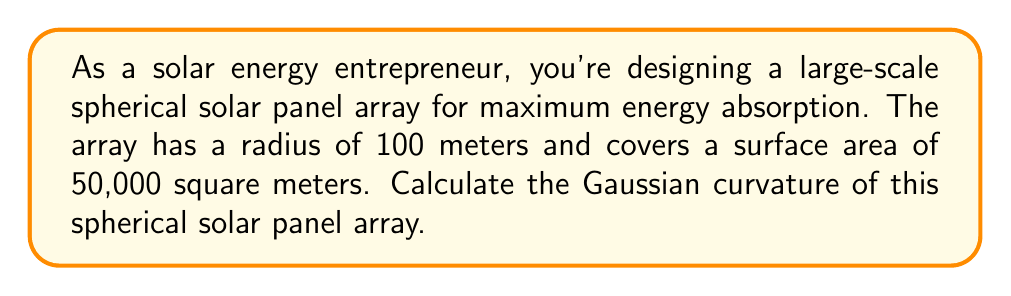Give your solution to this math problem. Let's approach this step-by-step:

1) The Gaussian curvature ($K$) of a sphere is constant and given by the formula:

   $$K = \frac{1}{R^2}$$

   where $R$ is the radius of the sphere.

2) We're given that the radius of the spherical array is 100 meters. Let's substitute this into our formula:

   $$K = \frac{1}{(100\text{ m})^2} = \frac{1}{10,000\text{ m}^2}$$

3) To simplify:
   
   $$K = 0.0001\text{ m}^{-2}$$

4) Note: We can verify our answer using the given surface area. The surface area of a sphere is given by $4\pi R^2$. With $R = 100\text{ m}$:

   $$4\pi(100\text{ m})^2 = 125,663.7\text{ m}^2$$

   The given surface area of 50,000 m² is less than this, which is consistent with a partial spherical array.

[asy]
import geometry;

size(200);
draw(Circle((0,0),1));
draw((0,0)--(1,0),Arrow);
label("R",(0.5,0),S);
label("Spherical solar panel array",(-0.7,0.7));
[/asy]
Answer: $0.0001\text{ m}^{-2}$ 